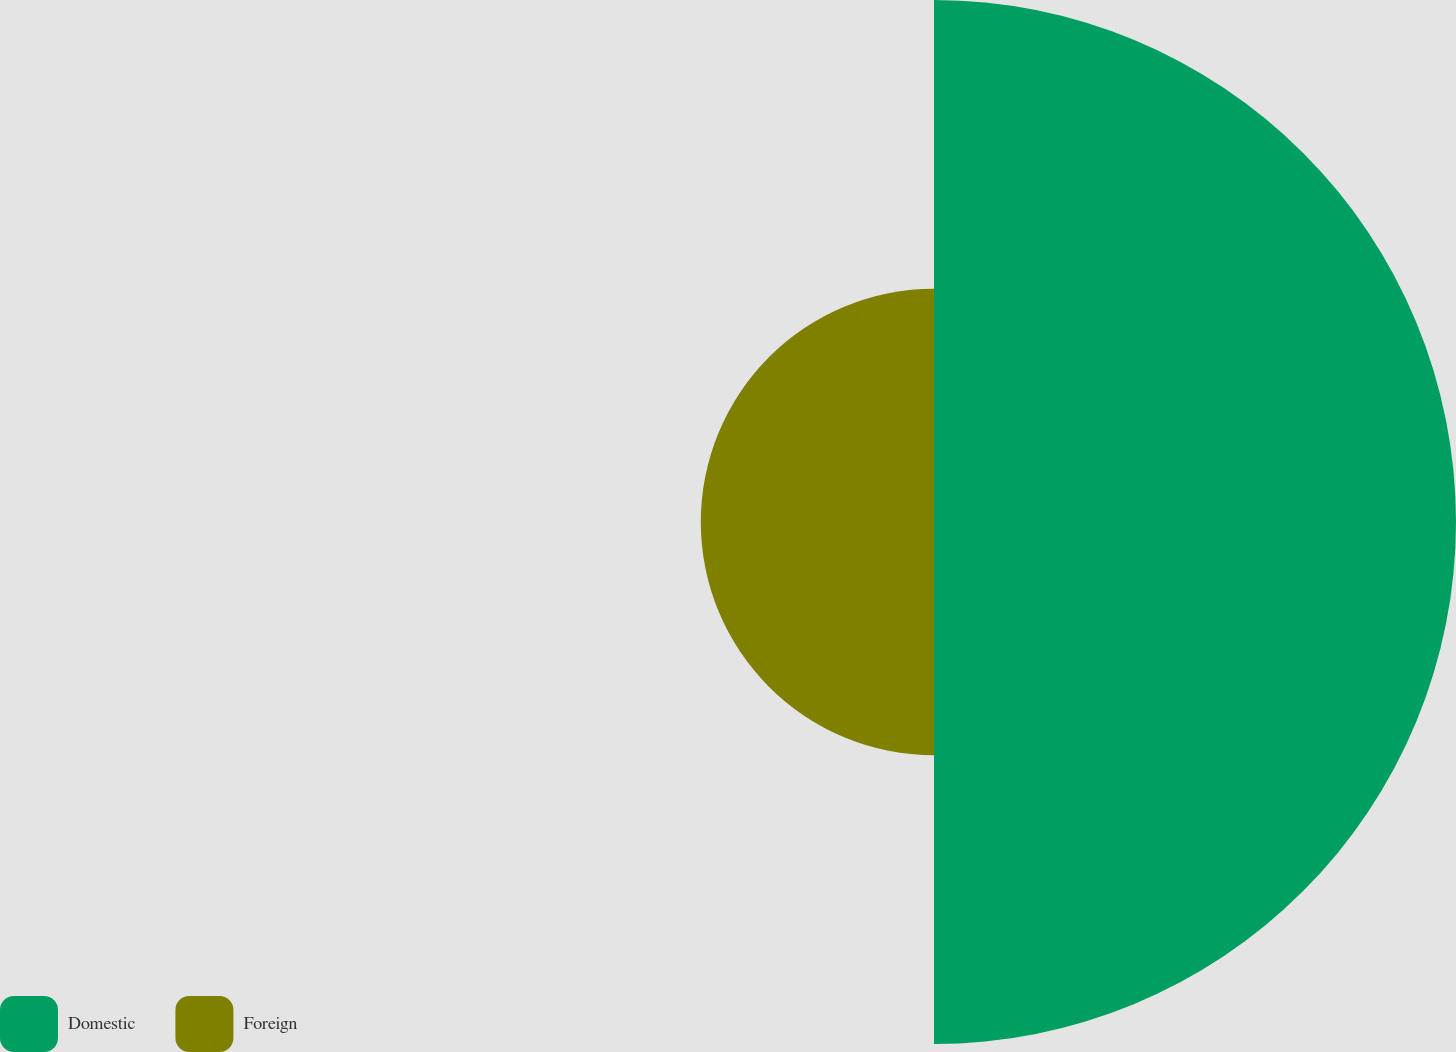Convert chart. <chart><loc_0><loc_0><loc_500><loc_500><pie_chart><fcel>Domestic<fcel>Foreign<nl><fcel>69.12%<fcel>30.88%<nl></chart> 